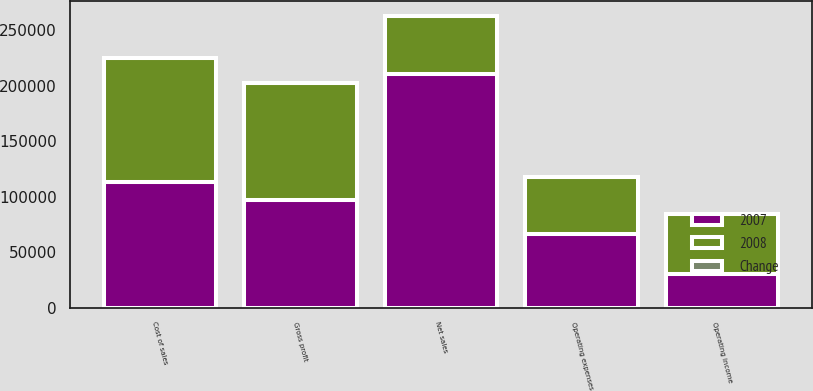Convert chart. <chart><loc_0><loc_0><loc_500><loc_500><stacked_bar_chart><ecel><fcel>Net sales<fcel>Cost of sales<fcel>Gross profit<fcel>Operating expenses<fcel>Operating income<nl><fcel>2007<fcel>210494<fcel>113187<fcel>97307<fcel>66781<fcel>30526<nl><fcel>2008<fcel>52670<fcel>111889<fcel>105340<fcel>51599<fcel>53741<nl><fcel>Change<fcel>3.1<fcel>1.2<fcel>7.6<fcel>29.4<fcel>43.2<nl></chart> 